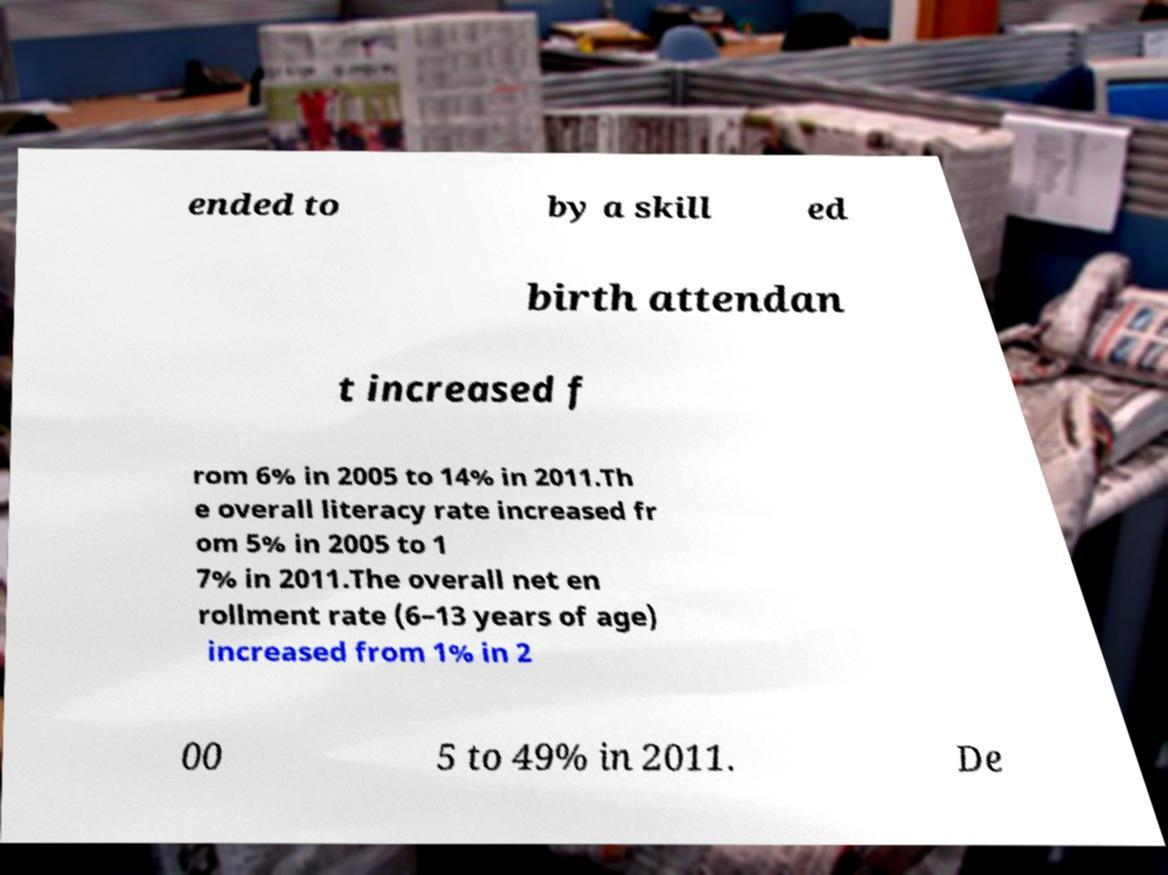What messages or text are displayed in this image? I need them in a readable, typed format. ended to by a skill ed birth attendan t increased f rom 6% in 2005 to 14% in 2011.Th e overall literacy rate increased fr om 5% in 2005 to 1 7% in 2011.The overall net en rollment rate (6–13 years of age) increased from 1% in 2 00 5 to 49% in 2011. De 